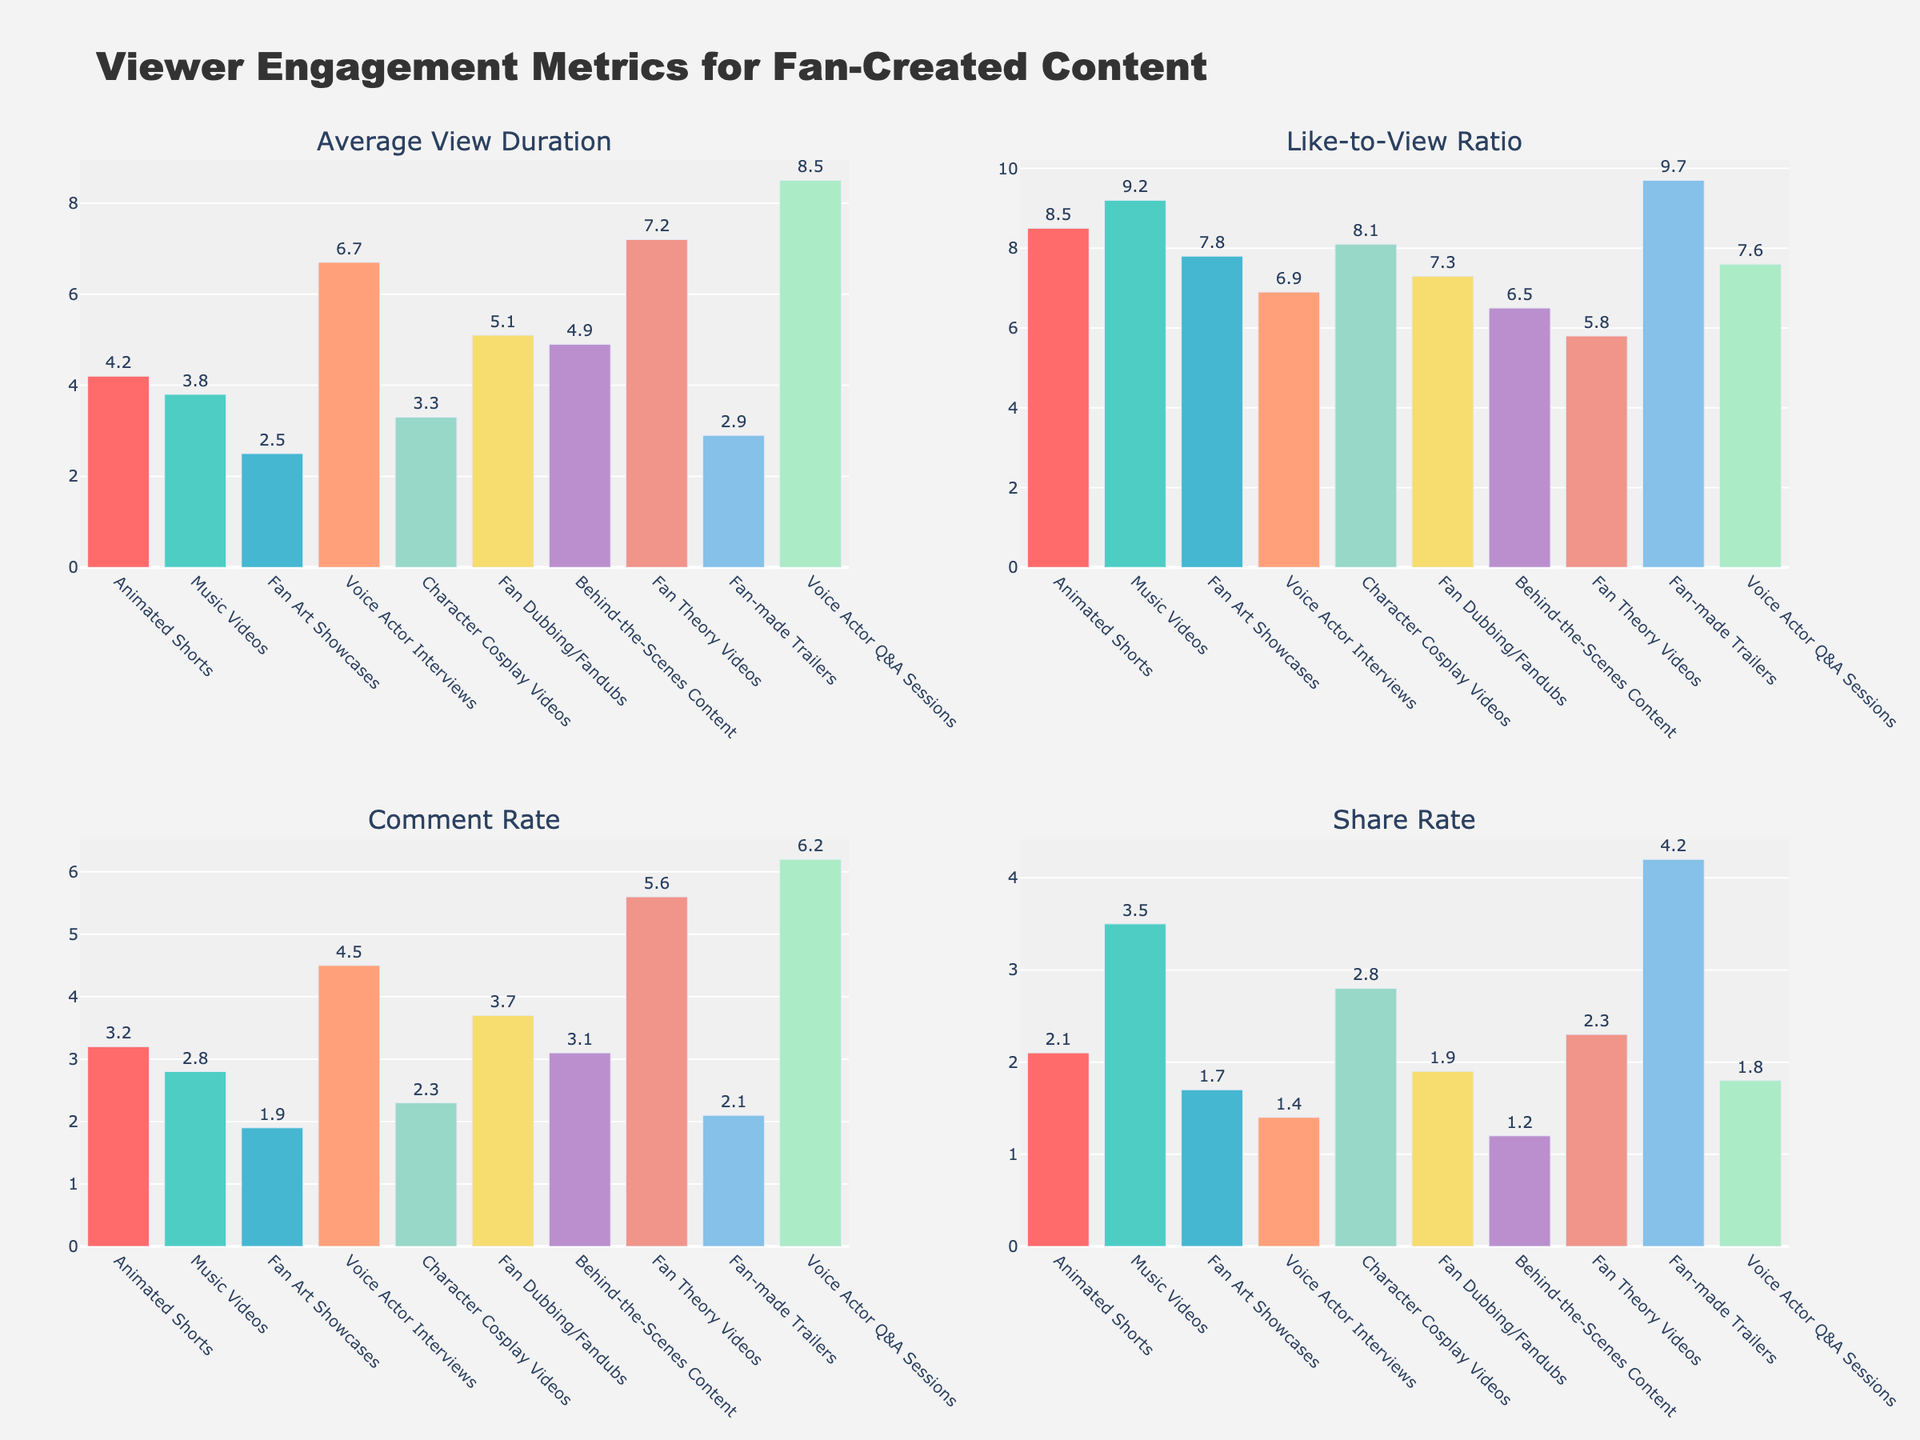What type of content has the highest average view duration? Locate the "Average View Duration" subplot. The tallest bar in this plot represents the type of content with the highest average view duration.
Answer: Voice Actor Q&A Sessions Which content has the lowest share rate? Locate the "Share Rate" subplot. The shortest bar in this plot represents the type of fan-created content with the lowest share rate.
Answer: Behind-the-Scenes Content What's the difference in the like-to-view ratio between Music Videos and Fan Theory Videos? In the "Like-to-View Ratio" subplot, identify the bars for Music Videos and Fan Theory Videos. Subtract Fan Theory Videos' value (5.8%) from Music Videos' value (9.2%) to find the difference.
Answer: 3.4% Which two types of content have the closest average view duration? In the "Average View Duration" subplot, compare the heights of the bars to find the two bars with the closest heights.
Answer: Behind-the-Scenes Content and Fan Dubbing/Fandubs Which content type gets the most comments as a percentage of views? Locate the "Comment Rate" subplot. The tallest bar in this plot represents the type of content with the highest comment rate.
Answer: Voice Actor Q&A Sessions What's the average like-to-view ratio for Animated Shorts and Fan Art Showcases? In the "Like-to-View Ratio" subplot, locate the bars for Animated Shorts (8.5%) and Fan Art Showcases (7.8%). Sum these values and divide by 2 to get the average.
Answer: 8.15% Compare the share rates of Fan-made Trailers and Character Cosplay Videos. Which one is higher and by how much? In the "Share Rate" subplot, identify the bars for Fan-made Trailers and Character Cosplay Videos. Subtract Character Cosplay Videos' value (2.8%) from Fan-made Trailers' value (4.2%), indicating that Fan-made Trailers' share rate is higher.
Answer: Fan-made Trailers by 1.4% If you wanted to focus on content that has both a high comment rate and share rate, which content type would you choose? Analyze the "Comment Rate" and "Share Rate" subplots. Look for content types with bars that are high in both subplots.
Answer: Fan Theory Videos How much higher is the average view duration of Voice Actor Interviews compared to Fan Art Showcases? In the "Average View Duration" subplot, subtract the value for Fan Art Showcases (2.5 minutes) from the value for Voice Actor Interviews (6.7 minutes) to get the difference.
Answer: 4.2 minutes What is the combined share rate for Music Videos and Animated Shorts? In the "Share Rate" subplot, identify the values for Music Videos (3.5%) and Animated Shorts (2.1%). Sum these values to get the combined share rate.
Answer: 5.6% 